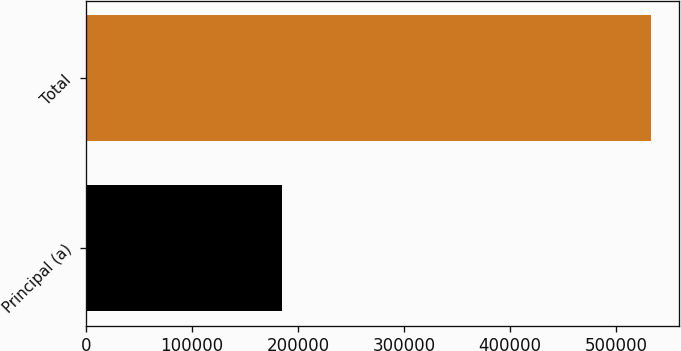<chart> <loc_0><loc_0><loc_500><loc_500><bar_chart><fcel>Principal (a)<fcel>Total<nl><fcel>184369<fcel>533284<nl></chart> 